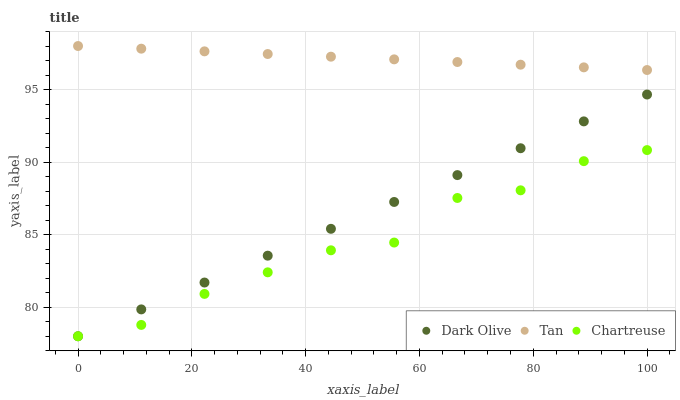Does Chartreuse have the minimum area under the curve?
Answer yes or no. Yes. Does Tan have the maximum area under the curve?
Answer yes or no. Yes. Does Dark Olive have the minimum area under the curve?
Answer yes or no. No. Does Dark Olive have the maximum area under the curve?
Answer yes or no. No. Is Tan the smoothest?
Answer yes or no. Yes. Is Chartreuse the roughest?
Answer yes or no. Yes. Is Dark Olive the smoothest?
Answer yes or no. No. Is Dark Olive the roughest?
Answer yes or no. No. Does Dark Olive have the lowest value?
Answer yes or no. Yes. Does Tan have the highest value?
Answer yes or no. Yes. Does Dark Olive have the highest value?
Answer yes or no. No. Is Chartreuse less than Tan?
Answer yes or no. Yes. Is Tan greater than Dark Olive?
Answer yes or no. Yes. Does Chartreuse intersect Dark Olive?
Answer yes or no. Yes. Is Chartreuse less than Dark Olive?
Answer yes or no. No. Is Chartreuse greater than Dark Olive?
Answer yes or no. No. Does Chartreuse intersect Tan?
Answer yes or no. No. 